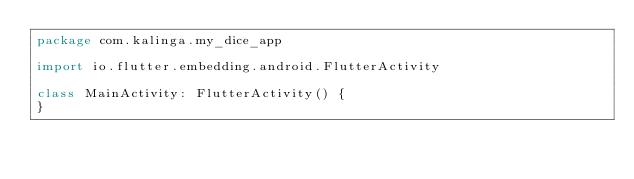<code> <loc_0><loc_0><loc_500><loc_500><_Kotlin_>package com.kalinga.my_dice_app

import io.flutter.embedding.android.FlutterActivity

class MainActivity: FlutterActivity() {
}
</code> 